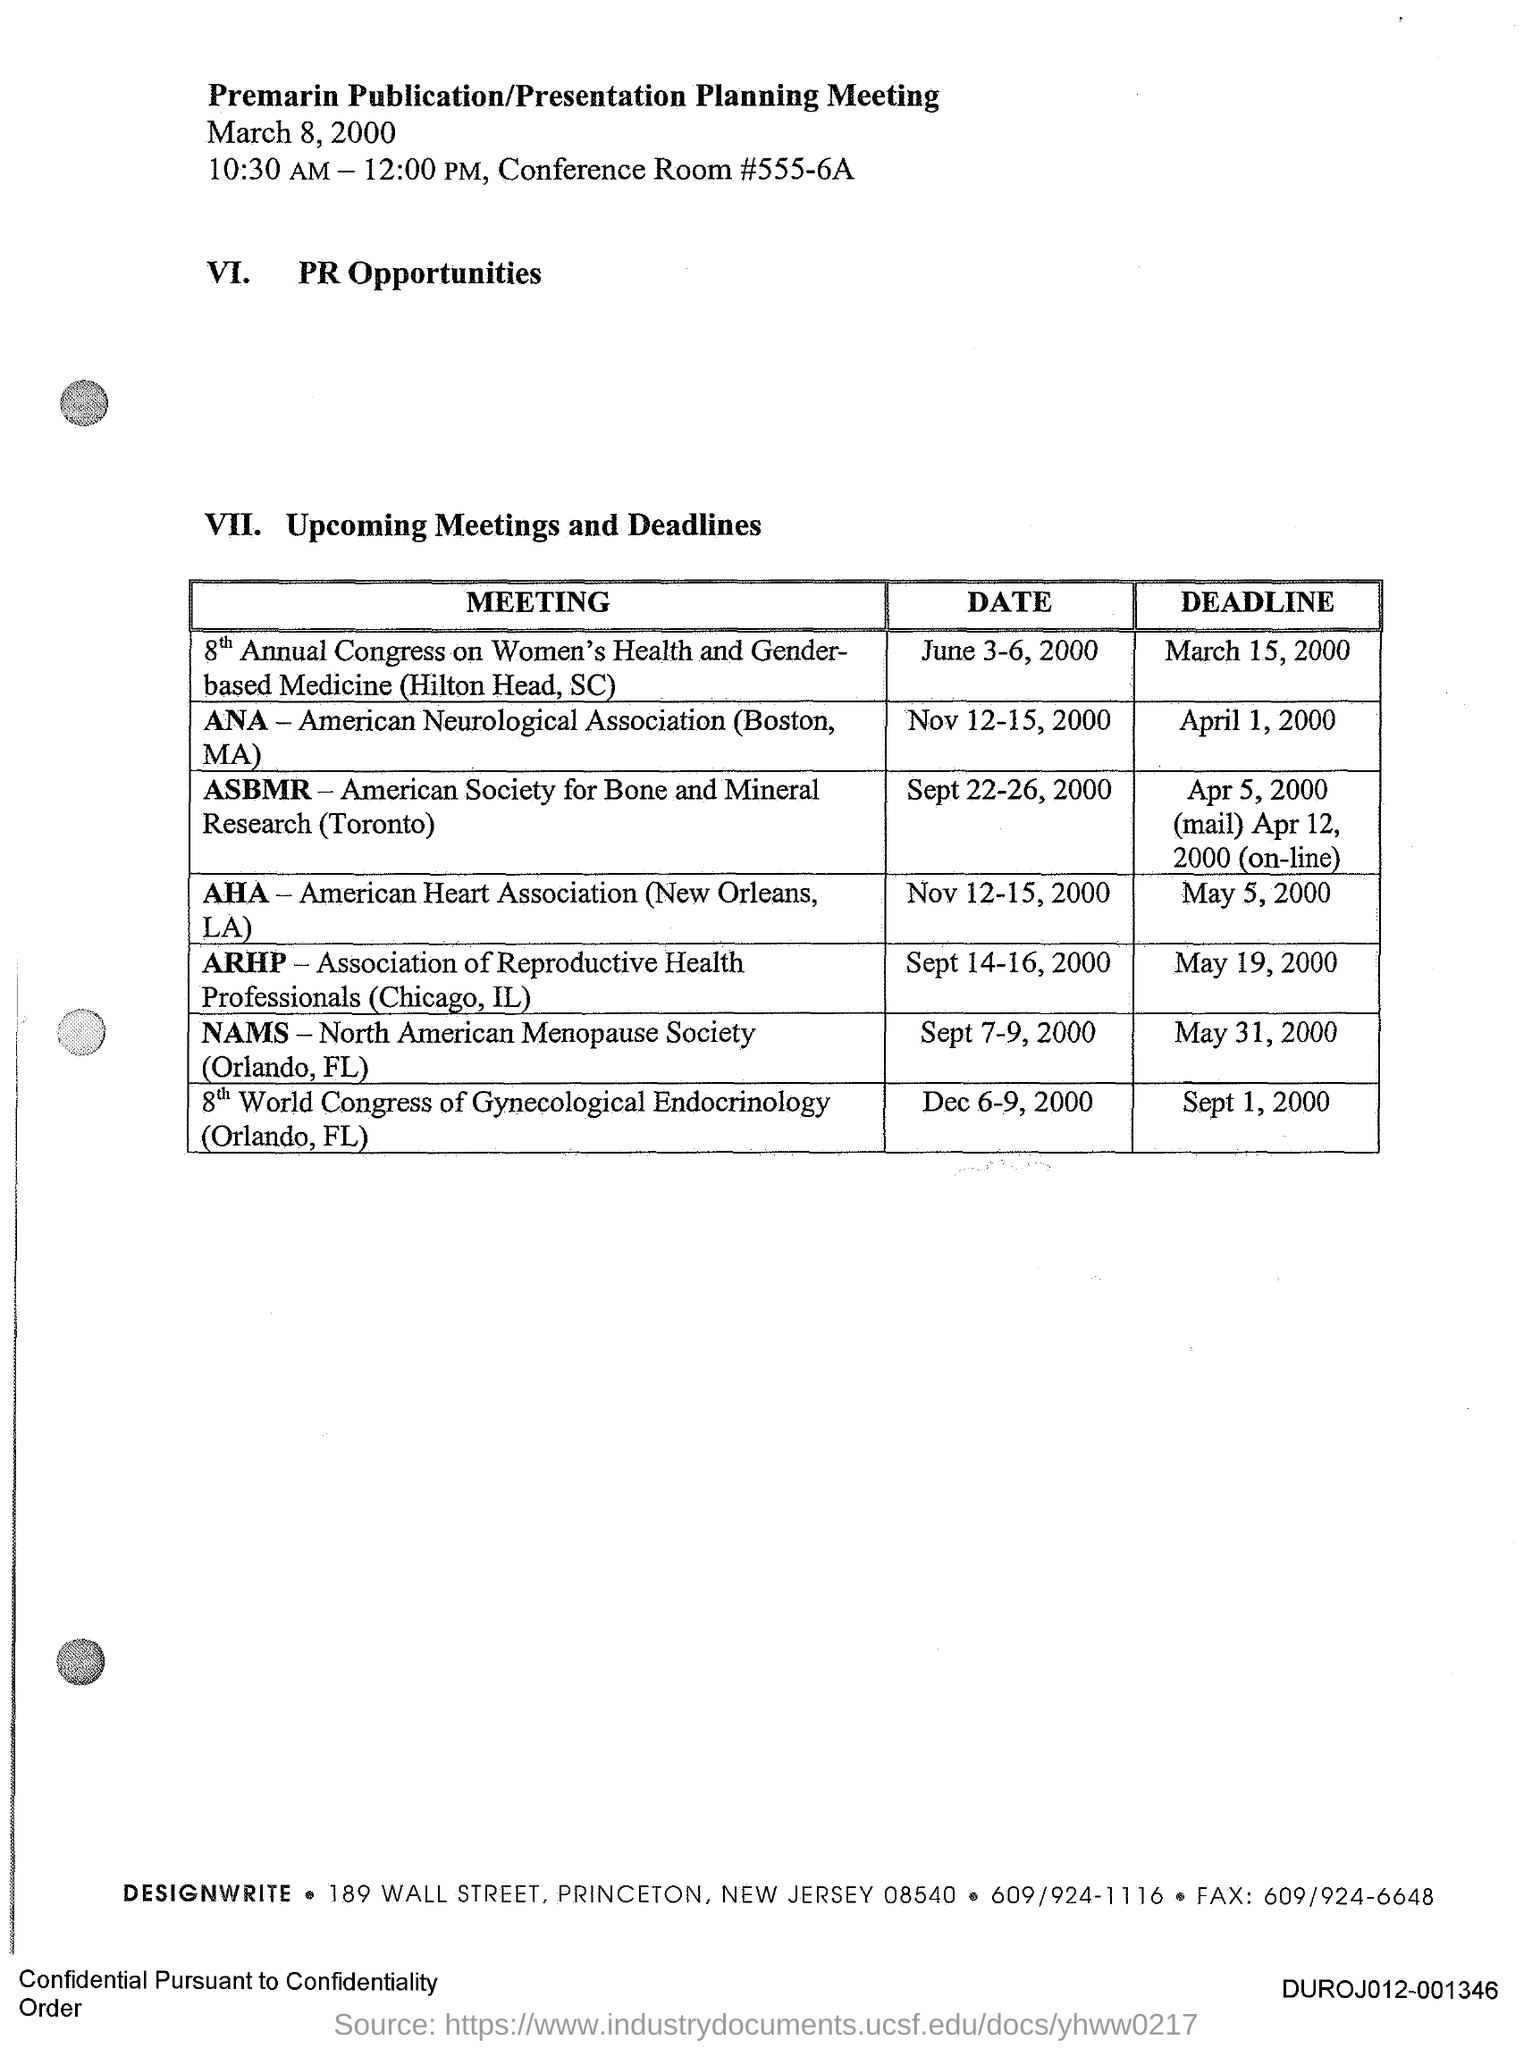What is the full form of AHA?
Your answer should be very brief. American Heart Association. What is the Fax number of DESIGNWRITE?
Offer a terse response. 609/924-6648. What is the title of the document?
Give a very brief answer. Premarin Publication/Presentation Planning Meeting. When is the deadline for "ANA"?
Offer a terse response. April 1, 2000. When is the deadline for "AHA"?
Your response must be concise. May 5,2000. 